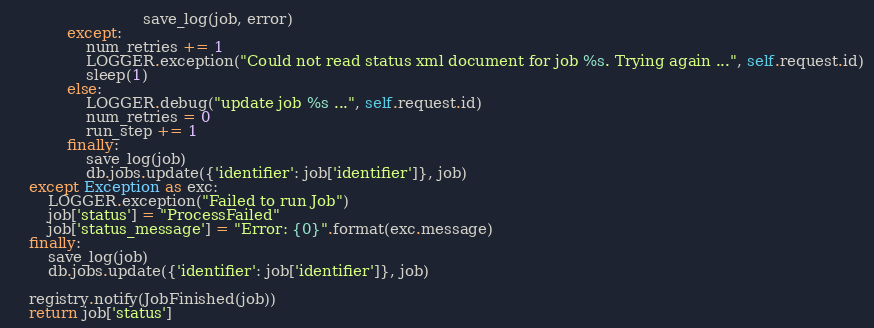<code> <loc_0><loc_0><loc_500><loc_500><_Python_>                            save_log(job, error)
            except:
                num_retries += 1
                LOGGER.exception("Could not read status xml document for job %s. Trying again ...", self.request.id)
                sleep(1)
            else:
                LOGGER.debug("update job %s ...", self.request.id)
                num_retries = 0
                run_step += 1
            finally:
                save_log(job)
                db.jobs.update({'identifier': job['identifier']}, job)
    except Exception as exc:
        LOGGER.exception("Failed to run Job")
        job['status'] = "ProcessFailed"
        job['status_message'] = "Error: {0}".format(exc.message)
    finally:
        save_log(job)
        db.jobs.update({'identifier': job['identifier']}, job)

    registry.notify(JobFinished(job))
    return job['status']
</code> 